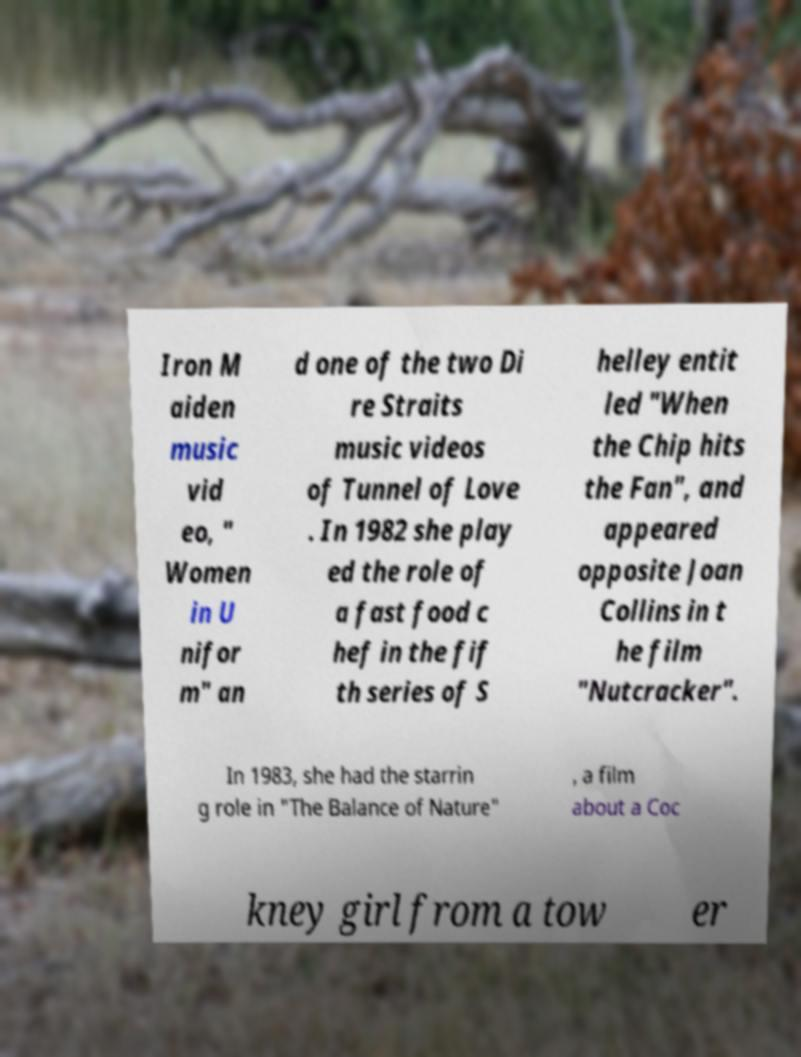What messages or text are displayed in this image? I need them in a readable, typed format. Iron M aiden music vid eo, " Women in U nifor m" an d one of the two Di re Straits music videos of Tunnel of Love . In 1982 she play ed the role of a fast food c hef in the fif th series of S helley entit led "When the Chip hits the Fan", and appeared opposite Joan Collins in t he film "Nutcracker". In 1983, she had the starrin g role in "The Balance of Nature" , a film about a Coc kney girl from a tow er 